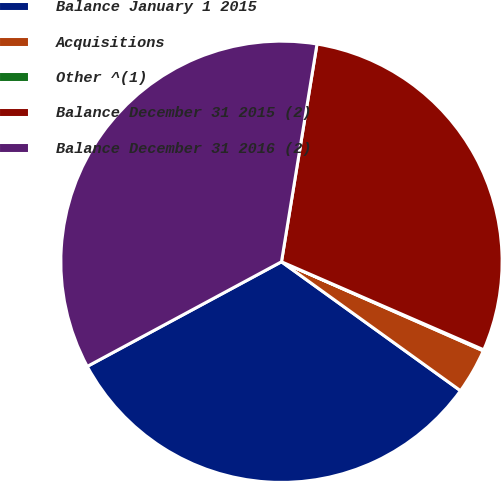Convert chart to OTSL. <chart><loc_0><loc_0><loc_500><loc_500><pie_chart><fcel>Balance January 1 2015<fcel>Acquisitions<fcel>Other ^(1)<fcel>Balance December 31 2015 (2)<fcel>Balance December 31 2016 (2)<nl><fcel>32.2%<fcel>3.32%<fcel>0.08%<fcel>28.96%<fcel>35.44%<nl></chart> 